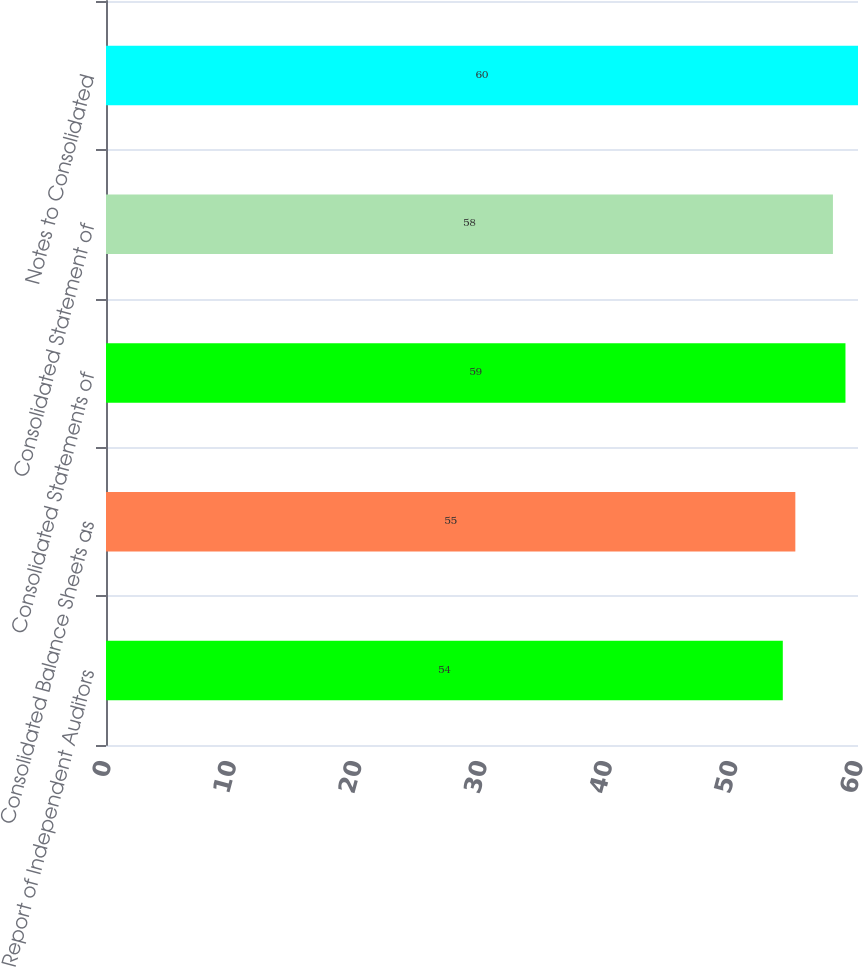Convert chart to OTSL. <chart><loc_0><loc_0><loc_500><loc_500><bar_chart><fcel>Report of Independent Auditors<fcel>Consolidated Balance Sheets as<fcel>Consolidated Statements of<fcel>Consolidated Statement of<fcel>Notes to Consolidated<nl><fcel>54<fcel>55<fcel>59<fcel>58<fcel>60<nl></chart> 